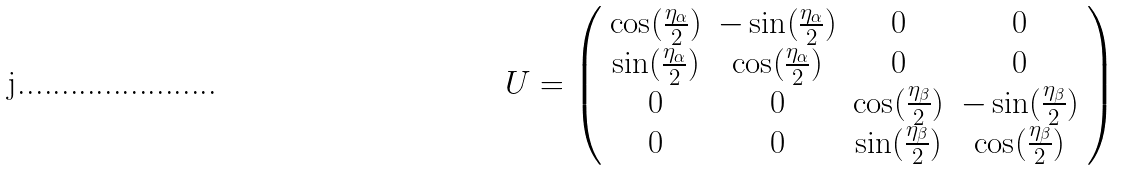Convert formula to latex. <formula><loc_0><loc_0><loc_500><loc_500>U = \left ( \begin{array} { c c c c } \cos ( \frac { \eta _ { \alpha } } { 2 } ) & - \sin ( \frac { \eta _ { \alpha } } { 2 } ) & 0 & 0 \\ \sin ( \frac { \eta _ { \alpha } } { 2 } ) & \cos ( \frac { \eta _ { \alpha } } { 2 } ) & 0 & 0 \\ 0 & 0 & \cos ( \frac { \eta _ { \beta } } { 2 } ) & - \sin ( \frac { \eta _ { \beta } } { 2 } ) \\ 0 & 0 & \sin ( \frac { \eta _ { \beta } } { 2 } ) & \cos ( \frac { \eta _ { \beta } } { 2 } ) \end{array} \right )</formula> 